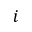<formula> <loc_0><loc_0><loc_500><loc_500>i</formula> 